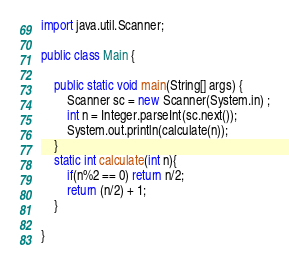Convert code to text. <code><loc_0><loc_0><loc_500><loc_500><_Java_>import java.util.Scanner;
 
public class Main {
 
	public static void main(String[] args) {
		Scanner sc = new Scanner(System.in) ;
		int n = Integer.parseInt(sc.next());
		System.out.println(calculate(n));
	}
	static int calculate(int n){
		if(n%2 == 0) return n/2;
		return (n/2) + 1;
	}
 
}</code> 